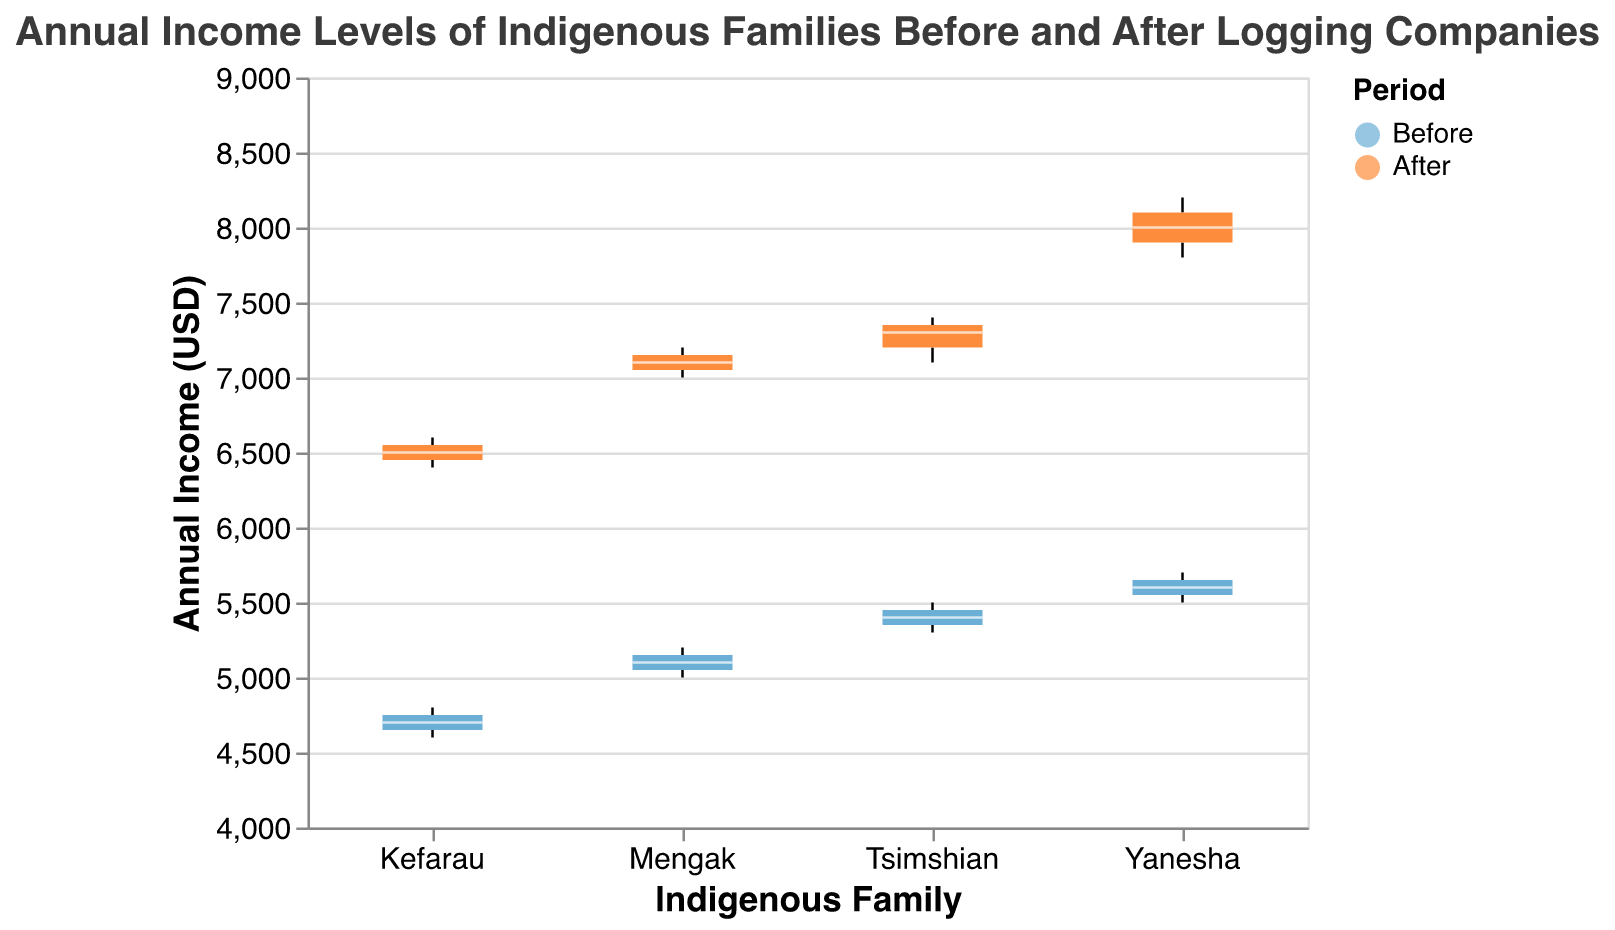What's the title of the plot? The title is displayed at the top of the figure and it summarizes the figure's content.
Answer: Annual Income Levels of Indigenous Families Before and After Logging Companies Which color represents the 'After' period? Colors are used in the legend to represent different periods. The 'After' period is assigned a specific color according to the legend.
Answer: Orange Which indigenous family has the highest median annual income after the introduction of logging companies? Look at the orange box plot for each family and identify the one with the highest median line. The Yanesha family has the highest median line among the orange box plots.
Answer: Yanesha What is the approximate annual income range for the Tsimshian family before the introduction of logging companies? Look at the blue box for the Tsimshian family and note the lower and upper ends of the box plot to get the income range. The lower end is around 5300 and the upper end is around 5500 USD.
Answer: 5300 to 5500 USD How does the median annual income of the Kefarau family change after the introduction of logging companies? Compare the median line of the blue box plot (Before) with the median line of the orange box plot (After) for the Kefarau family. The median shifts from around 4700 USD to around 6500 USD.
Answer: Increases by 1800 USD What family showed the most significant increase in median annual income after the introduction of logging companies? Compare the before and after median lines for each family. The Yanesha family shows a significant increase from around 5600 USD to around 8000 USD.
Answer: Yanesha What is the interquartile range (IQR) of the Yanesha family's annual income before the introduction of logging companies? Calculate the difference between the third quartile (Q3) and the first quartile (Q1) by looking at the ends of the blue box plot for the Yanesha family. Q3 is around 5700 and Q1 is around 5500. 5700 - 5500 = 200.
Answer: 200 USD Which period has a higher maximum annual income for the Tsimshian family? Compare the highest data point of the blue box plot (Before) with the highest data point of the orange box plot (After) for the Tsimshian family. The orange box plot shows a higher maximum.
Answer: After What is the median annual income for the Mengak family before the introduction of logging companies? Look at the blue box plot for the Mengak family and note the position of the median line. The median is around 5100 USD.
Answer: 5100 USD 